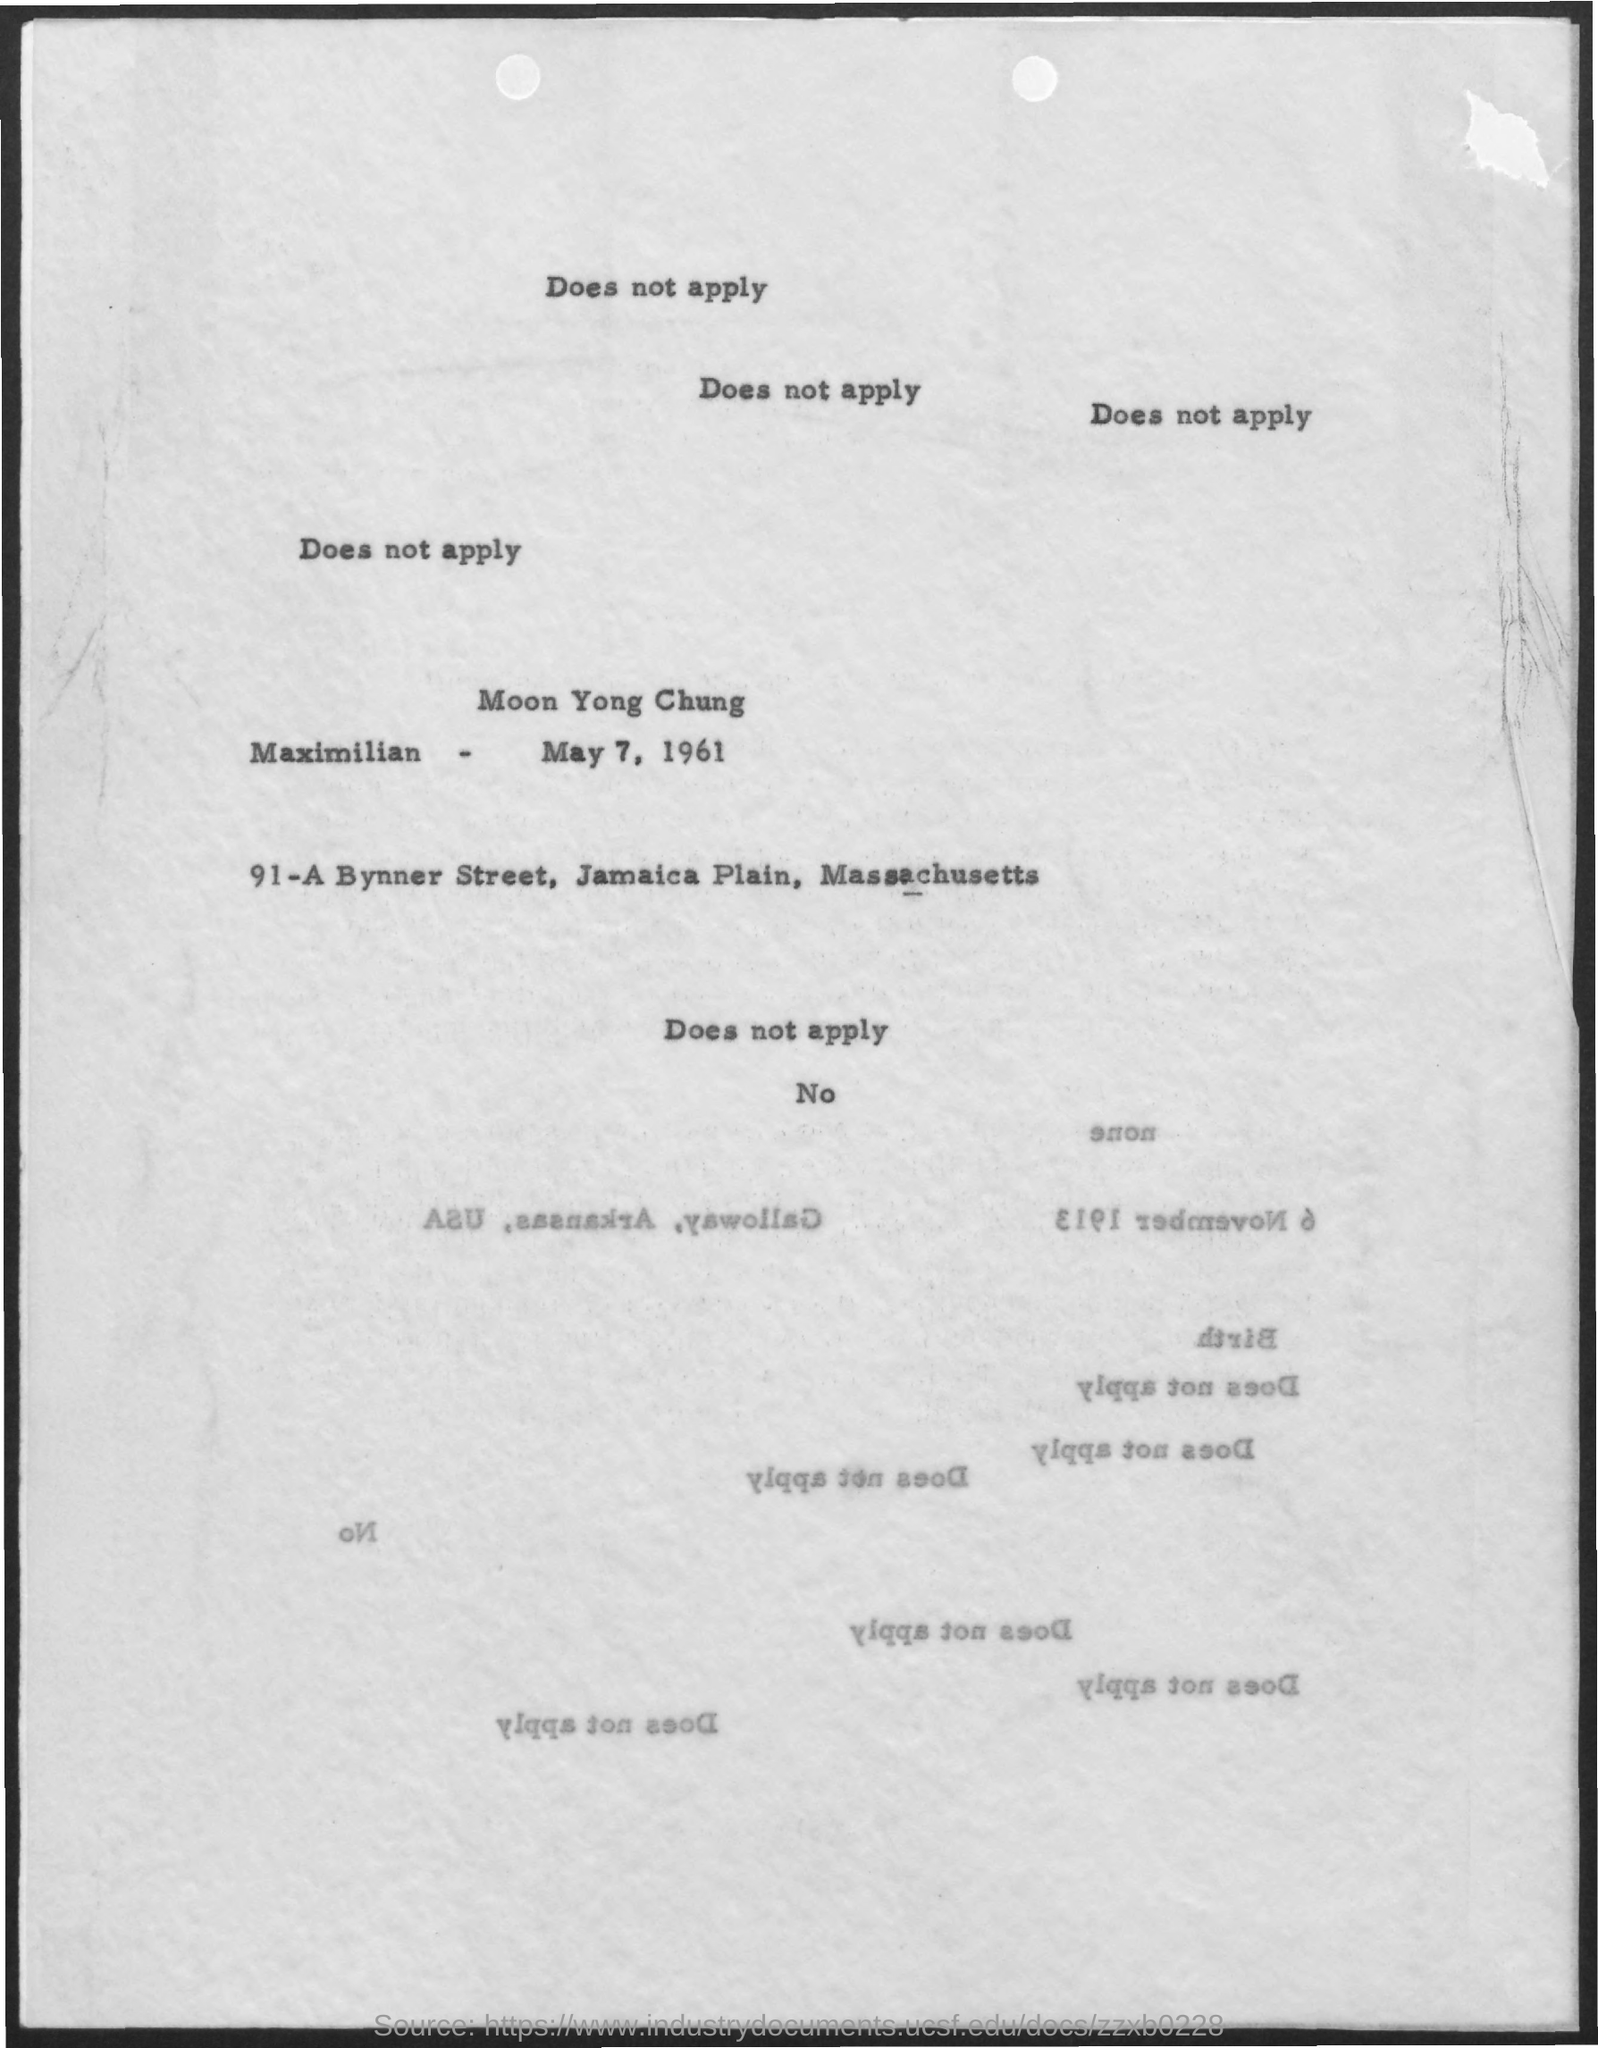What is the date mentioned in the given page ?
Make the answer very short. MAY 7, 1961. 